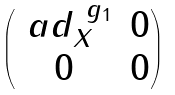<formula> <loc_0><loc_0><loc_500><loc_500>\begin{pmatrix} \ a d ^ { \ g _ { 1 } } _ { X } & 0 \\ 0 & 0 \end{pmatrix}</formula> 